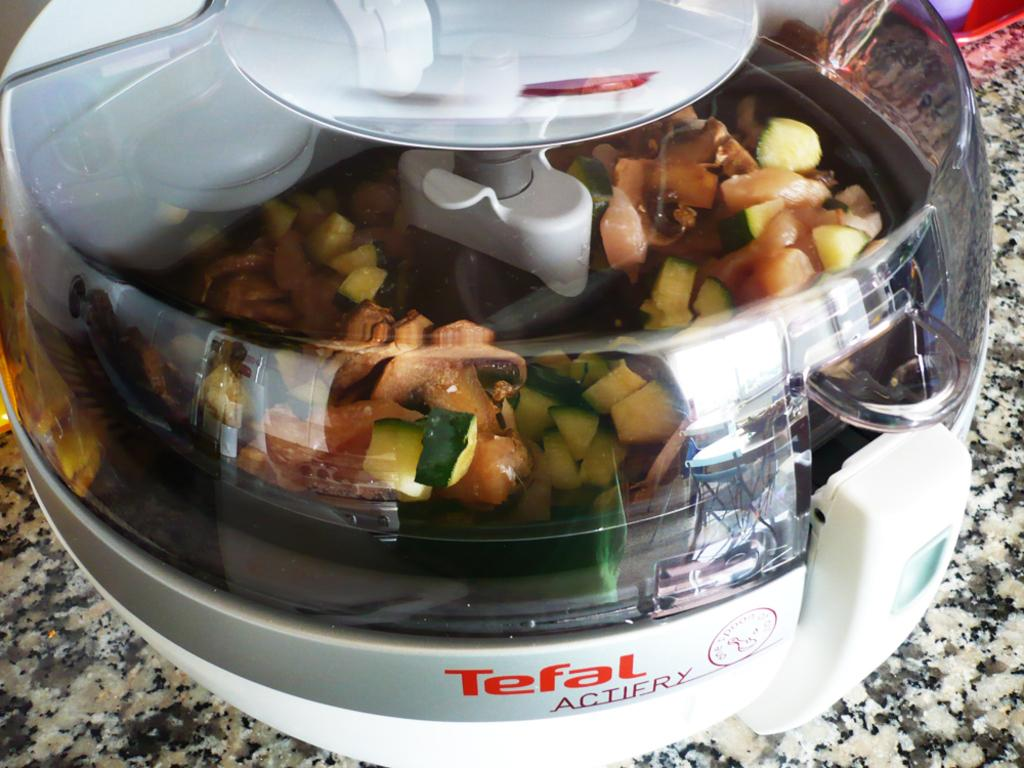What appliance is visible in the image? There is a blender in the image. What is inside the blender? There is some stuff in the blender. What shape is the cent in the image? There is no cent present in the image, and therefore no shape can be determined. 